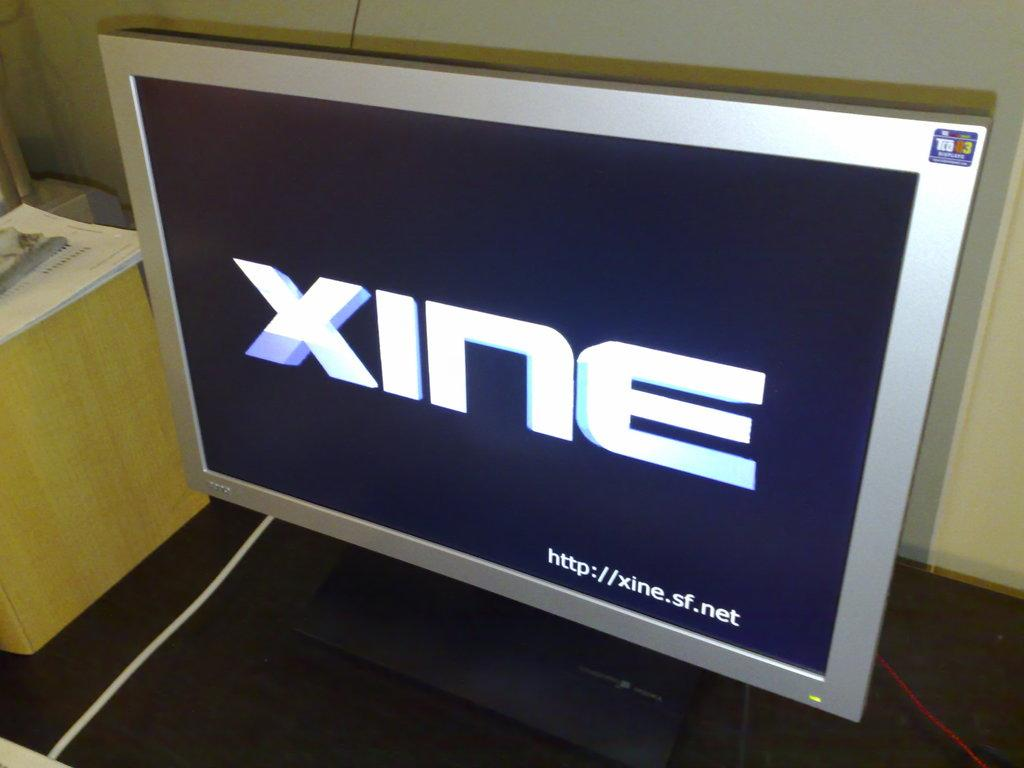<image>
Provide a brief description of the given image. A square computer monitor displaying the word Xine. 